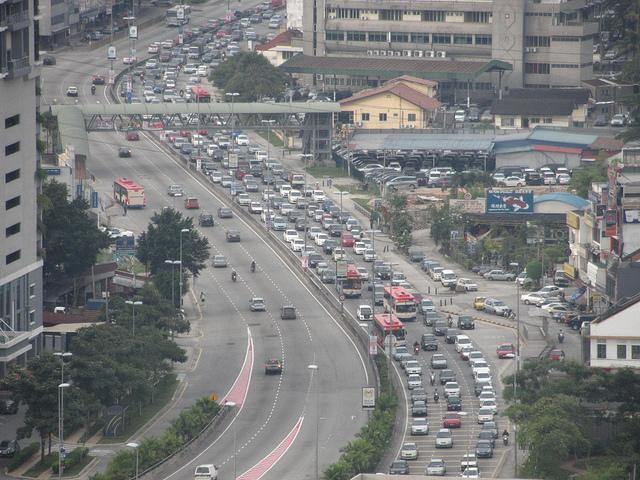What time is it likely to be?
Answer the question by selecting the correct answer among the 4 following choices and explain your choice with a short sentence. The answer should be formatted with the following format: `Answer: choice
Rationale: rationale.`
Options: Noon, 845 am, midnight, dusk. Answer: 845 am.
Rationale: People are commuting in rush hour traffic. 